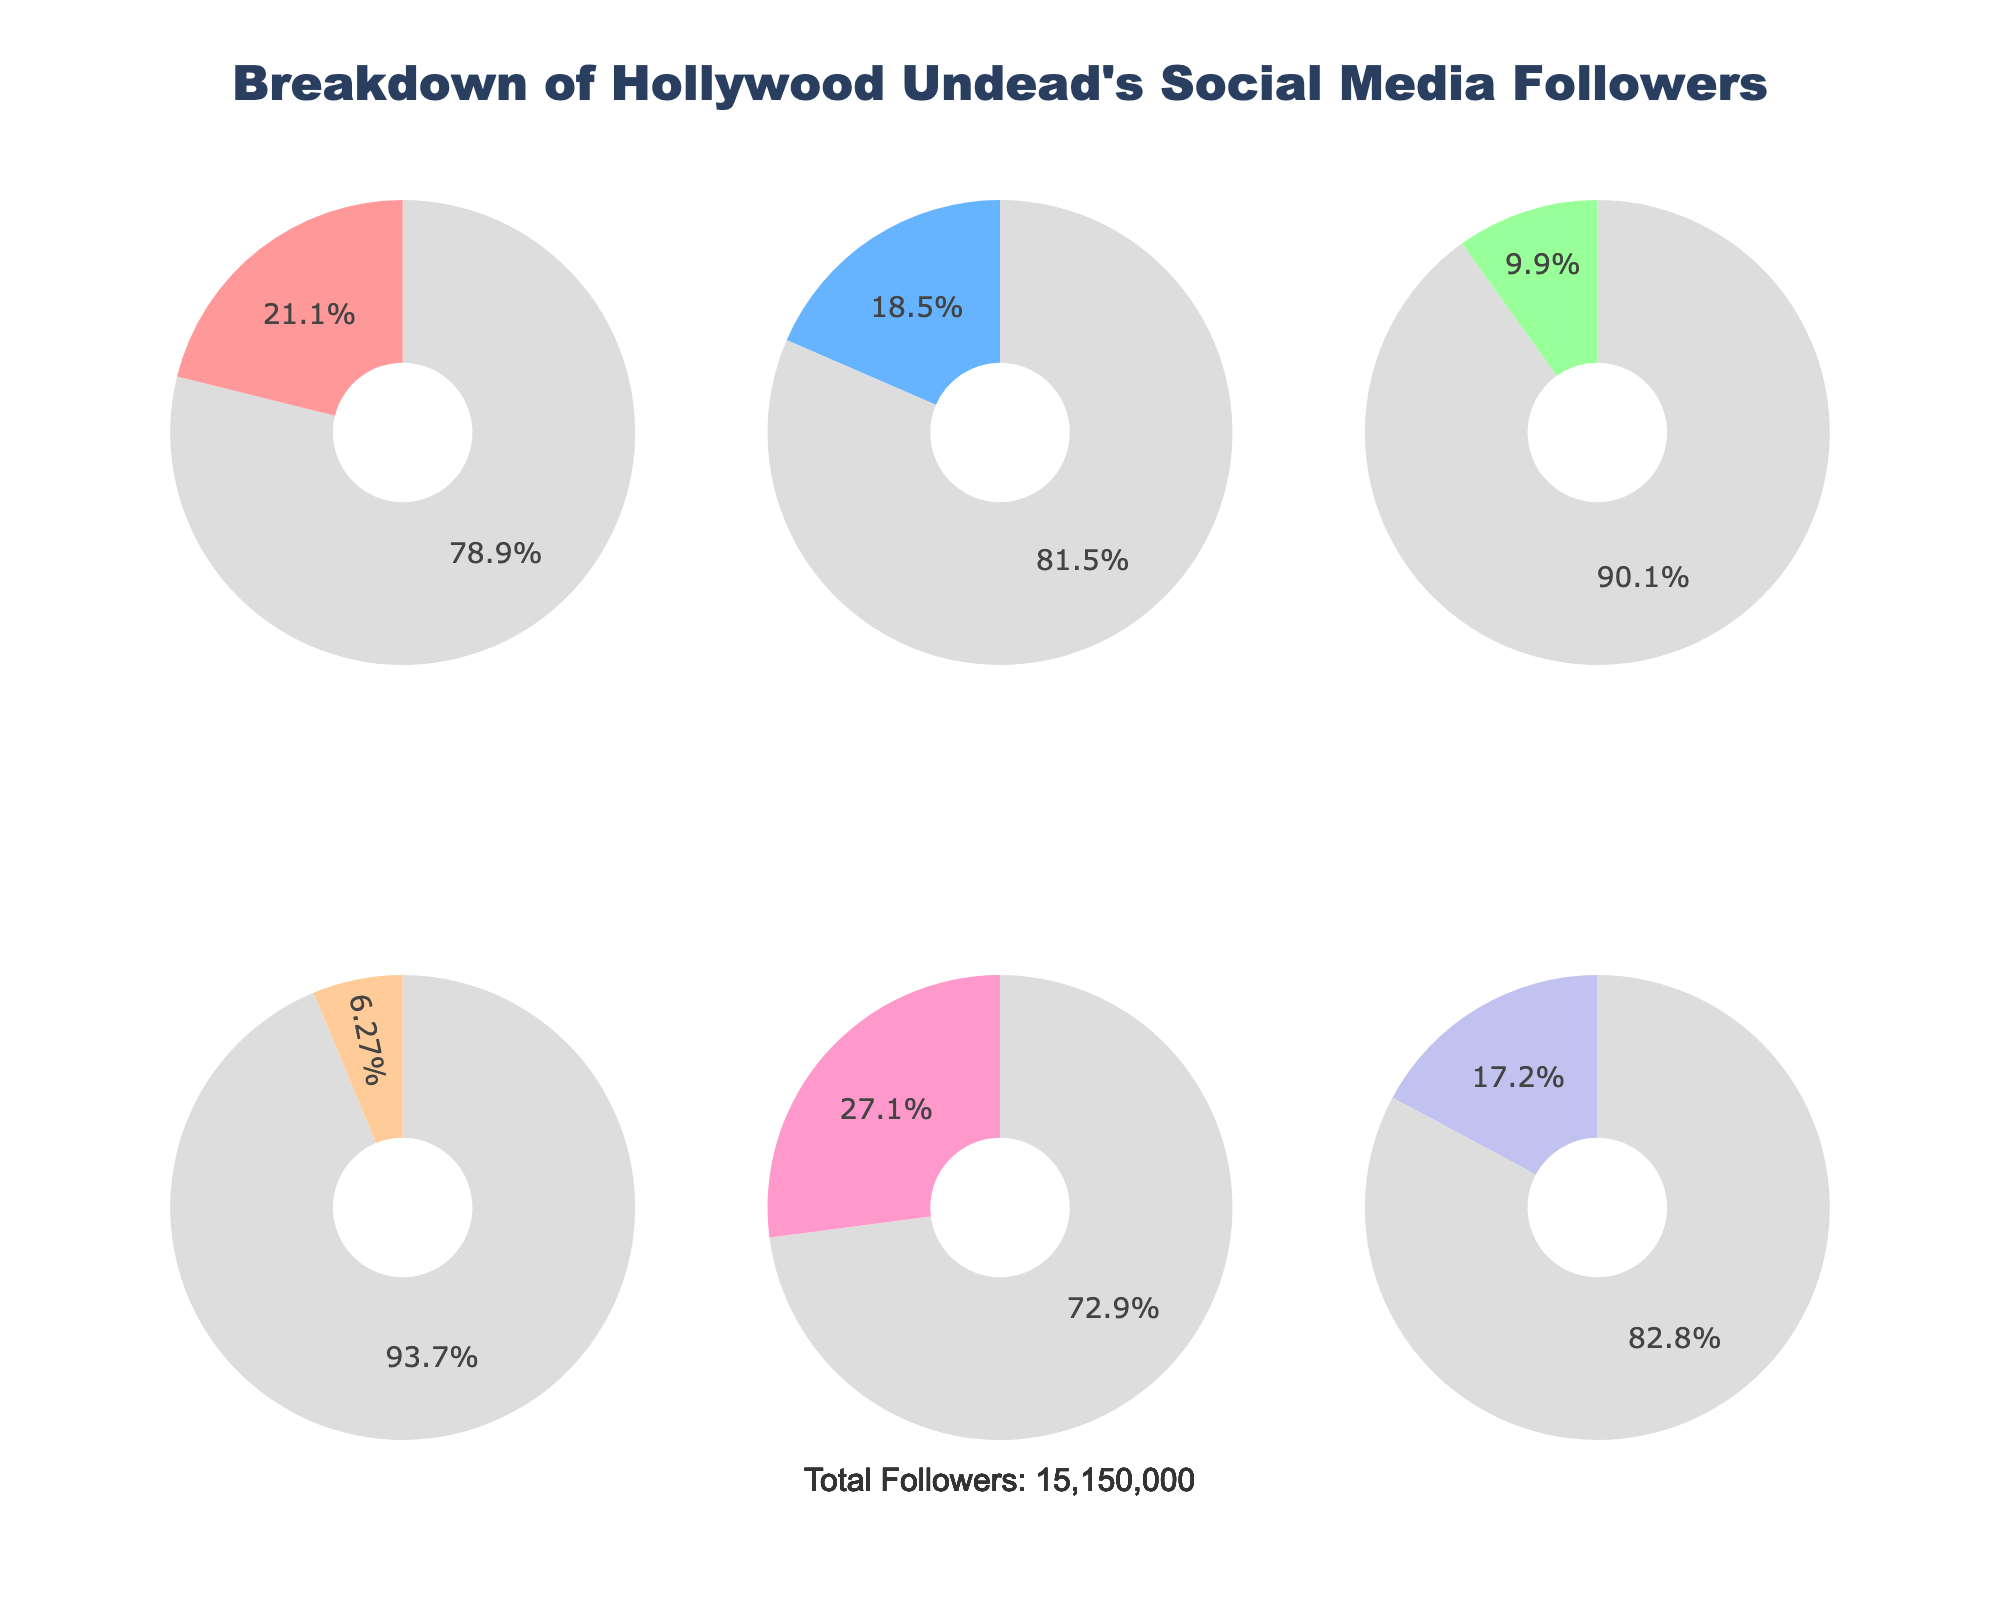What is the title of the figure? The title is placed prominently at the top of the figure. It provides an overview of the content displayed in the figure. The title reads "Breakdown of Hollywood Undead's Social Media Followers".
Answer: Breakdown of Hollywood Undead's Social Media Followers Which platform has the most followers? By comparing the sizes of the slices in each pie chart, the YouTube pie chart has the largest "Followers" slice. The title of this subplot confirms it.
Answer: YouTube What is the total number of followers across all platforms? The figure includes an annotation at the bottom that reads "Total Followers: 15,250,000". This number is the sum of the follower counts of all the platforms.
Answer: 15,250,000 Which platform has the least followers? By observing the pie charts, the TikTok pie chart has the smallest "Followers" slice. The title of this subplot confirms that TikTok has the fewest followers.
Answer: TikTok How many followers does Spotify have? Looking at the pie chart labeled Spotify, it is indicated that Spotify has 2,600,000 followers.
Answer: 2,600,000 Is the number of Instagram followers greater than Twitter followers? By comparing the number of followers indicated in the pie charts for Instagram and Twitter, Instagram (3,200,000) has more followers than Twitter (1,500,000).
Answer: Yes What percentage of Hollywood Undead's total social media followers are on Instagram? The percentage can be estimated by looking at the size of the Instagram slice and the text on its pie chart, showing the "Followers" percentage. With Instagram having 3,200,000 followers out of a total of 15,250,000 followers, it calculates to approximately (3,200,000/15,250,000) * 100 = 21.0%.
Answer: 21.0% How do the followers on Facebook compare to those on YouTube? By comparing the sizes of the slices and checking the values under each pie chart title, YouTube has 4,100,000 followers and Facebook has 2,800,000 followers. Hence, YouTube has more followers than Facebook.
Answer: YouTube has more followers If Facebook and Twitter combined their followers, would they surpass YouTube? The followers of Facebook (2,800,000) and Twitter (1,500,000) would add up to 4,300,000, which is greater than the 4,100,000 YouTube followers, so they would surpass YouTube.
Answer: Yes Which platform's followers make up approximately 17% of the total followers? By looking at the pie charts and their percentage texts, the Spotify pie chart shows approximately 17% of the total followers, which aligns closely with its follower count (2,600,000) relative to the total (15,250,000).
Answer: Spotify 